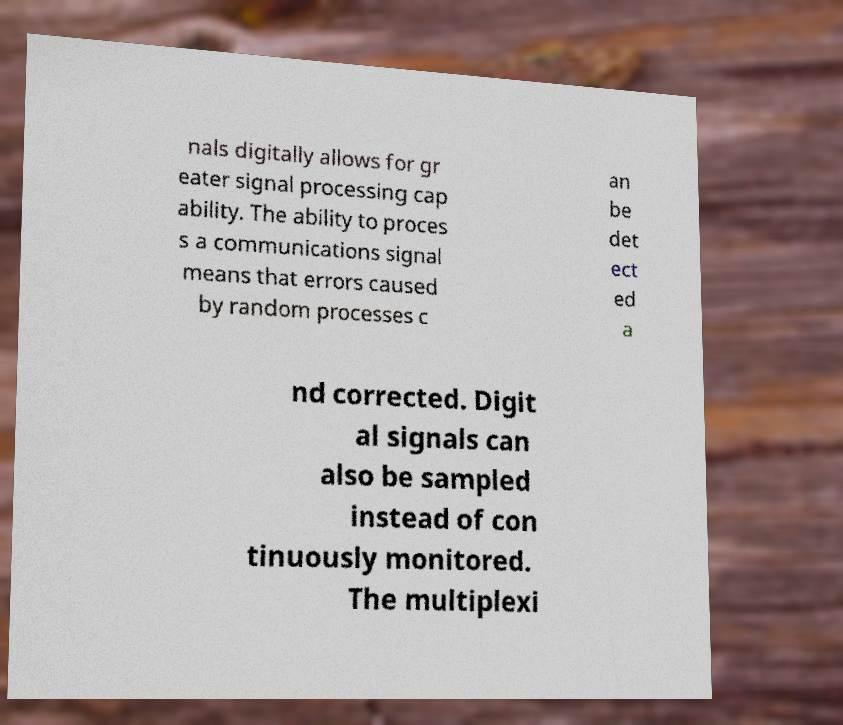Can you read and provide the text displayed in the image?This photo seems to have some interesting text. Can you extract and type it out for me? nals digitally allows for gr eater signal processing cap ability. The ability to proces s a communications signal means that errors caused by random processes c an be det ect ed a nd corrected. Digit al signals can also be sampled instead of con tinuously monitored. The multiplexi 